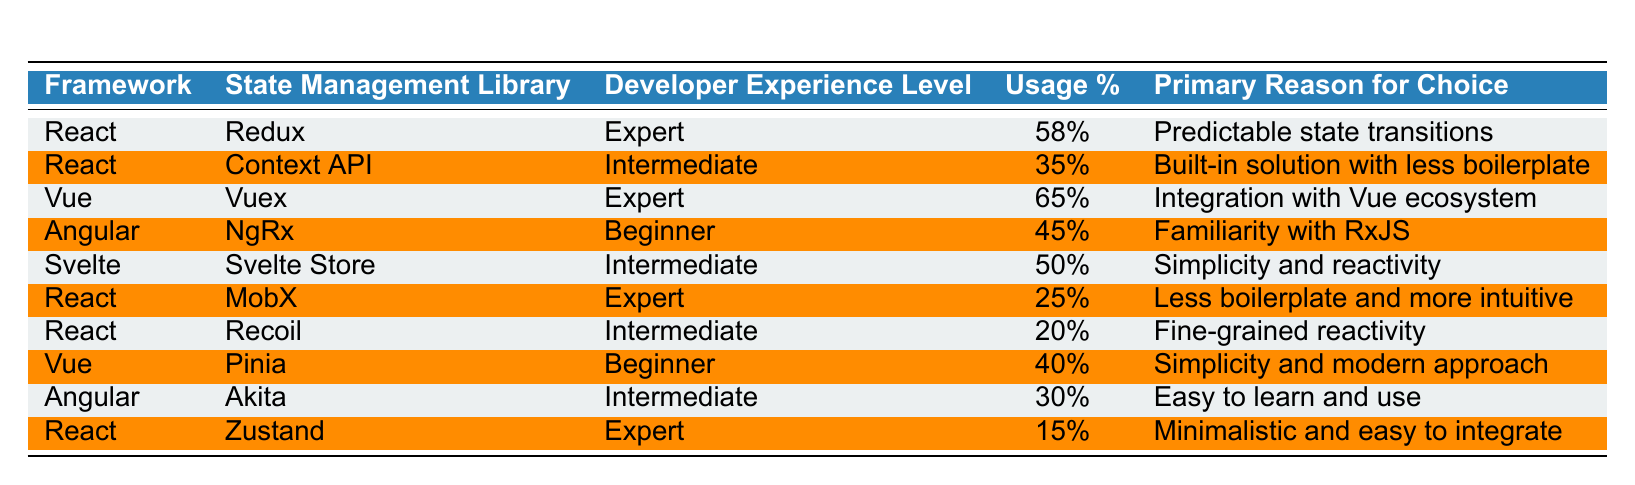What is the state management library used by experts in React? From the table, filter for the "React" framework and the "Expert" experience level. The state management library listed is "Redux."
Answer: Redux What percentage of intermediate developers use the Context API in React? The table shows the usage percentage under the "State Management Library" for "Context API" with "Intermediate" experience level, which is 35%.
Answer: 35% Which state management library has the highest usage percentage among Vue developers? Looking at the "Vue" framework, "Vuex" has the highest usage percentage at 65%.
Answer: Vuex Is MobX used more by expert or intermediate developers according to the data? Check the levels of experience listed for "MobX." It shows "Expert" with 25%, while there are no "Intermediate" users listed. Hence, it is primarily used by experts.
Answer: Yes, by experts What is the primary reason for using NgRx among beginner Angular developers? The table lists "Familiarity with RxJS" as the primary reason for "NgRx" used by "Beginner" developers in Angular.
Answer: Familiarity with RxJS Calculate the average usage percentage of state management libraries for beginners across all frameworks. The usage percentages for beginners are 45% (NgRx), 40% (Pinia). Add these (45 + 40 = 85) and divide by the number of entries (2), resulting in an average of 42.5%.
Answer: 42.5% What percentage of expert React developers use Zustand? For the "React" framework under the "Expert" experience level, Zustand has a usage percentage of 15%.
Answer: 15% Which framework has the lowest overall usage of their state management library? Compare the percentages: Redux (58%), Context API (35%), Vuex (65%), NgRx (45%), Svelte Store (50%), MobX (25%), Recoil (20%), Pinia (40%), Akita (30%), and Zustand (15%). The lowest is Zustand at 15%.
Answer: Zustand Do any intermediate developers use both Recoil and Context API in React? The data shows "Intermediate" developers using Context API (35%) and Recoil (20%), but it does not specify they are the same developers. Thus, it's possible but not certain.
Answer: Unknown Identify the primary reason for the choice of Svelte Store by intermediate developers. The table specifies "Simplicity and reactivity" as the primary reason for "Svelte Store" among intermediate developers.
Answer: Simplicity and reactivity 